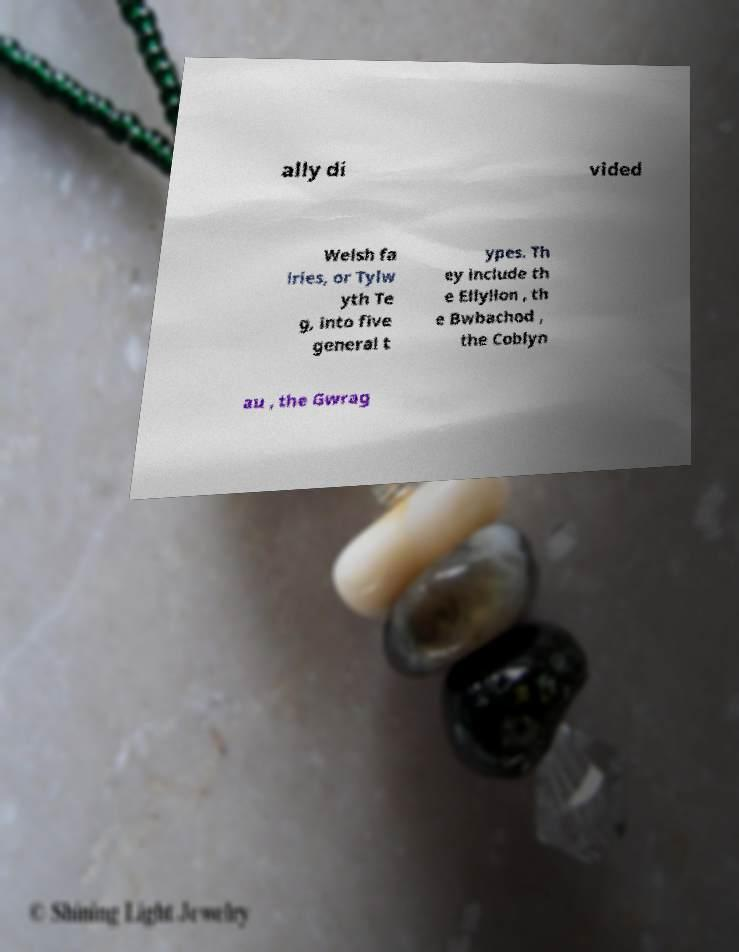There's text embedded in this image that I need extracted. Can you transcribe it verbatim? ally di vided Welsh fa iries, or Tylw yth Te g, into five general t ypes. Th ey include th e Ellyllon , th e Bwbachod , the Coblyn au , the Gwrag 